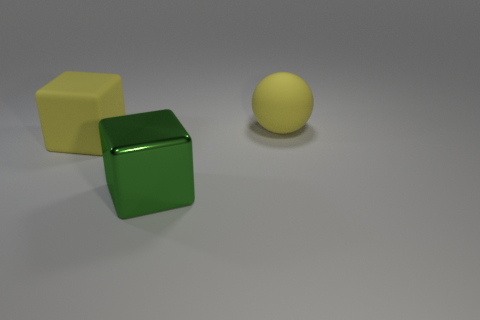Add 2 matte cubes. How many objects exist? 5 Subtract all cubes. How many objects are left? 1 Subtract 1 spheres. How many spheres are left? 0 Subtract 0 blue cylinders. How many objects are left? 3 Subtract all gray cubes. Subtract all red balls. How many cubes are left? 2 Subtract all green metal cylinders. Subtract all shiny objects. How many objects are left? 2 Add 2 big metal blocks. How many big metal blocks are left? 3 Add 1 large purple matte cylinders. How many large purple matte cylinders exist? 1 